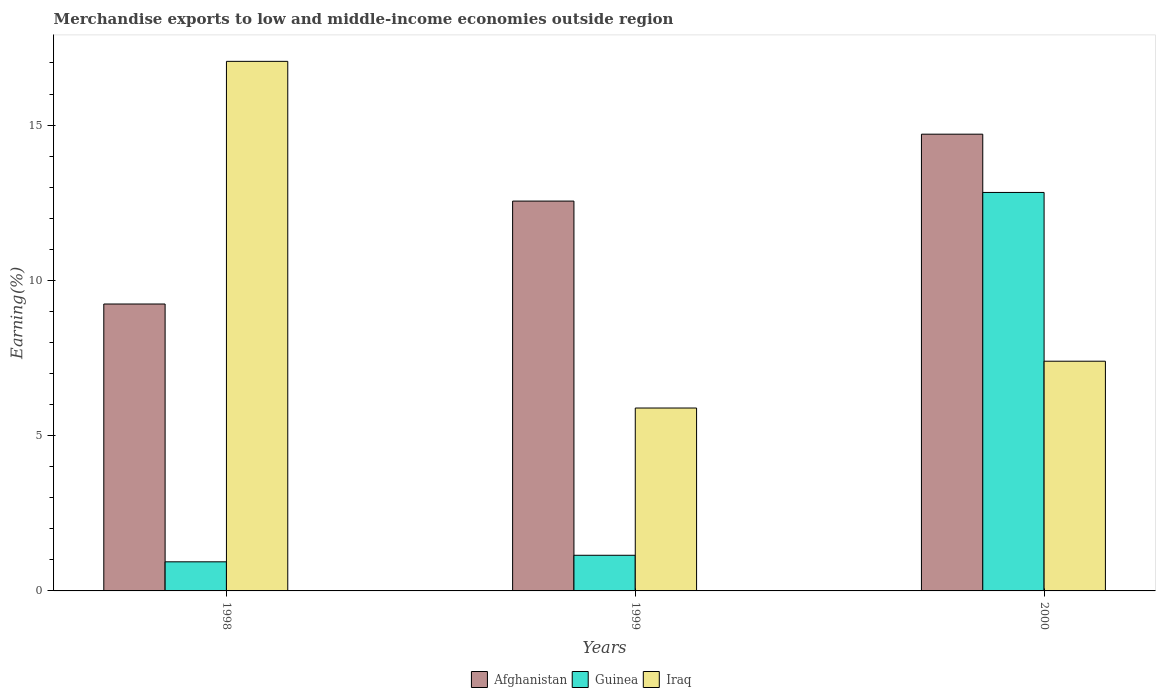How many groups of bars are there?
Make the answer very short. 3. Are the number of bars on each tick of the X-axis equal?
Your answer should be compact. Yes. How many bars are there on the 3rd tick from the left?
Provide a short and direct response. 3. What is the label of the 1st group of bars from the left?
Make the answer very short. 1998. What is the percentage of amount earned from merchandise exports in Iraq in 1999?
Provide a short and direct response. 5.89. Across all years, what is the maximum percentage of amount earned from merchandise exports in Afghanistan?
Your response must be concise. 14.71. Across all years, what is the minimum percentage of amount earned from merchandise exports in Guinea?
Provide a short and direct response. 0.94. In which year was the percentage of amount earned from merchandise exports in Afghanistan maximum?
Give a very brief answer. 2000. In which year was the percentage of amount earned from merchandise exports in Guinea minimum?
Make the answer very short. 1998. What is the total percentage of amount earned from merchandise exports in Guinea in the graph?
Provide a short and direct response. 14.92. What is the difference between the percentage of amount earned from merchandise exports in Iraq in 1998 and that in 1999?
Provide a succinct answer. 11.16. What is the difference between the percentage of amount earned from merchandise exports in Iraq in 1998 and the percentage of amount earned from merchandise exports in Afghanistan in 1999?
Provide a short and direct response. 4.5. What is the average percentage of amount earned from merchandise exports in Guinea per year?
Offer a very short reply. 4.97. In the year 1999, what is the difference between the percentage of amount earned from merchandise exports in Guinea and percentage of amount earned from merchandise exports in Afghanistan?
Your answer should be very brief. -11.41. In how many years, is the percentage of amount earned from merchandise exports in Iraq greater than 1 %?
Your response must be concise. 3. What is the ratio of the percentage of amount earned from merchandise exports in Guinea in 1999 to that in 2000?
Offer a very short reply. 0.09. Is the percentage of amount earned from merchandise exports in Iraq in 1999 less than that in 2000?
Your response must be concise. Yes. Is the difference between the percentage of amount earned from merchandise exports in Guinea in 1998 and 1999 greater than the difference between the percentage of amount earned from merchandise exports in Afghanistan in 1998 and 1999?
Keep it short and to the point. Yes. What is the difference between the highest and the second highest percentage of amount earned from merchandise exports in Guinea?
Make the answer very short. 11.68. What is the difference between the highest and the lowest percentage of amount earned from merchandise exports in Guinea?
Provide a short and direct response. 11.89. What does the 2nd bar from the left in 2000 represents?
Offer a terse response. Guinea. What does the 1st bar from the right in 2000 represents?
Your response must be concise. Iraq. Is it the case that in every year, the sum of the percentage of amount earned from merchandise exports in Afghanistan and percentage of amount earned from merchandise exports in Iraq is greater than the percentage of amount earned from merchandise exports in Guinea?
Keep it short and to the point. Yes. Are all the bars in the graph horizontal?
Ensure brevity in your answer.  No. What is the difference between two consecutive major ticks on the Y-axis?
Make the answer very short. 5. Does the graph contain any zero values?
Ensure brevity in your answer.  No. Does the graph contain grids?
Make the answer very short. No. Where does the legend appear in the graph?
Give a very brief answer. Bottom center. How are the legend labels stacked?
Make the answer very short. Horizontal. What is the title of the graph?
Offer a terse response. Merchandise exports to low and middle-income economies outside region. Does "Barbados" appear as one of the legend labels in the graph?
Your answer should be compact. No. What is the label or title of the Y-axis?
Provide a succinct answer. Earning(%). What is the Earning(%) in Afghanistan in 1998?
Keep it short and to the point. 9.24. What is the Earning(%) of Guinea in 1998?
Offer a very short reply. 0.94. What is the Earning(%) of Iraq in 1998?
Your response must be concise. 17.05. What is the Earning(%) in Afghanistan in 1999?
Provide a succinct answer. 12.55. What is the Earning(%) in Guinea in 1999?
Provide a succinct answer. 1.15. What is the Earning(%) in Iraq in 1999?
Your response must be concise. 5.89. What is the Earning(%) in Afghanistan in 2000?
Give a very brief answer. 14.71. What is the Earning(%) of Guinea in 2000?
Offer a very short reply. 12.83. What is the Earning(%) in Iraq in 2000?
Offer a very short reply. 7.4. Across all years, what is the maximum Earning(%) in Afghanistan?
Your answer should be very brief. 14.71. Across all years, what is the maximum Earning(%) in Guinea?
Provide a short and direct response. 12.83. Across all years, what is the maximum Earning(%) in Iraq?
Ensure brevity in your answer.  17.05. Across all years, what is the minimum Earning(%) in Afghanistan?
Your answer should be very brief. 9.24. Across all years, what is the minimum Earning(%) of Guinea?
Offer a very short reply. 0.94. Across all years, what is the minimum Earning(%) of Iraq?
Offer a very short reply. 5.89. What is the total Earning(%) in Afghanistan in the graph?
Offer a very short reply. 36.5. What is the total Earning(%) in Guinea in the graph?
Give a very brief answer. 14.92. What is the total Earning(%) in Iraq in the graph?
Offer a terse response. 30.34. What is the difference between the Earning(%) in Afghanistan in 1998 and that in 1999?
Provide a succinct answer. -3.31. What is the difference between the Earning(%) of Guinea in 1998 and that in 1999?
Provide a succinct answer. -0.21. What is the difference between the Earning(%) in Iraq in 1998 and that in 1999?
Your answer should be compact. 11.16. What is the difference between the Earning(%) in Afghanistan in 1998 and that in 2000?
Provide a succinct answer. -5.47. What is the difference between the Earning(%) of Guinea in 1998 and that in 2000?
Your answer should be compact. -11.89. What is the difference between the Earning(%) of Iraq in 1998 and that in 2000?
Your answer should be compact. 9.66. What is the difference between the Earning(%) of Afghanistan in 1999 and that in 2000?
Make the answer very short. -2.15. What is the difference between the Earning(%) in Guinea in 1999 and that in 2000?
Your response must be concise. -11.68. What is the difference between the Earning(%) of Iraq in 1999 and that in 2000?
Provide a short and direct response. -1.51. What is the difference between the Earning(%) of Afghanistan in 1998 and the Earning(%) of Guinea in 1999?
Give a very brief answer. 8.09. What is the difference between the Earning(%) in Afghanistan in 1998 and the Earning(%) in Iraq in 1999?
Keep it short and to the point. 3.35. What is the difference between the Earning(%) in Guinea in 1998 and the Earning(%) in Iraq in 1999?
Give a very brief answer. -4.95. What is the difference between the Earning(%) of Afghanistan in 1998 and the Earning(%) of Guinea in 2000?
Your response must be concise. -3.59. What is the difference between the Earning(%) of Afghanistan in 1998 and the Earning(%) of Iraq in 2000?
Keep it short and to the point. 1.84. What is the difference between the Earning(%) of Guinea in 1998 and the Earning(%) of Iraq in 2000?
Offer a terse response. -6.46. What is the difference between the Earning(%) of Afghanistan in 1999 and the Earning(%) of Guinea in 2000?
Your answer should be compact. -0.28. What is the difference between the Earning(%) in Afghanistan in 1999 and the Earning(%) in Iraq in 2000?
Give a very brief answer. 5.16. What is the difference between the Earning(%) of Guinea in 1999 and the Earning(%) of Iraq in 2000?
Offer a very short reply. -6.25. What is the average Earning(%) in Afghanistan per year?
Provide a short and direct response. 12.17. What is the average Earning(%) in Guinea per year?
Offer a very short reply. 4.97. What is the average Earning(%) of Iraq per year?
Provide a succinct answer. 10.11. In the year 1998, what is the difference between the Earning(%) of Afghanistan and Earning(%) of Guinea?
Offer a terse response. 8.3. In the year 1998, what is the difference between the Earning(%) in Afghanistan and Earning(%) in Iraq?
Your answer should be very brief. -7.81. In the year 1998, what is the difference between the Earning(%) in Guinea and Earning(%) in Iraq?
Your answer should be compact. -16.11. In the year 1999, what is the difference between the Earning(%) of Afghanistan and Earning(%) of Guinea?
Provide a succinct answer. 11.41. In the year 1999, what is the difference between the Earning(%) of Afghanistan and Earning(%) of Iraq?
Your answer should be very brief. 6.66. In the year 1999, what is the difference between the Earning(%) in Guinea and Earning(%) in Iraq?
Provide a succinct answer. -4.74. In the year 2000, what is the difference between the Earning(%) of Afghanistan and Earning(%) of Guinea?
Offer a very short reply. 1.88. In the year 2000, what is the difference between the Earning(%) of Afghanistan and Earning(%) of Iraq?
Provide a succinct answer. 7.31. In the year 2000, what is the difference between the Earning(%) in Guinea and Earning(%) in Iraq?
Provide a succinct answer. 5.43. What is the ratio of the Earning(%) in Afghanistan in 1998 to that in 1999?
Ensure brevity in your answer.  0.74. What is the ratio of the Earning(%) in Guinea in 1998 to that in 1999?
Make the answer very short. 0.82. What is the ratio of the Earning(%) in Iraq in 1998 to that in 1999?
Keep it short and to the point. 2.9. What is the ratio of the Earning(%) in Afghanistan in 1998 to that in 2000?
Your answer should be very brief. 0.63. What is the ratio of the Earning(%) in Guinea in 1998 to that in 2000?
Keep it short and to the point. 0.07. What is the ratio of the Earning(%) of Iraq in 1998 to that in 2000?
Provide a succinct answer. 2.31. What is the ratio of the Earning(%) in Afghanistan in 1999 to that in 2000?
Offer a terse response. 0.85. What is the ratio of the Earning(%) of Guinea in 1999 to that in 2000?
Keep it short and to the point. 0.09. What is the ratio of the Earning(%) in Iraq in 1999 to that in 2000?
Offer a terse response. 0.8. What is the difference between the highest and the second highest Earning(%) of Afghanistan?
Provide a succinct answer. 2.15. What is the difference between the highest and the second highest Earning(%) of Guinea?
Keep it short and to the point. 11.68. What is the difference between the highest and the second highest Earning(%) in Iraq?
Give a very brief answer. 9.66. What is the difference between the highest and the lowest Earning(%) of Afghanistan?
Offer a terse response. 5.47. What is the difference between the highest and the lowest Earning(%) in Guinea?
Ensure brevity in your answer.  11.89. What is the difference between the highest and the lowest Earning(%) of Iraq?
Your answer should be very brief. 11.16. 